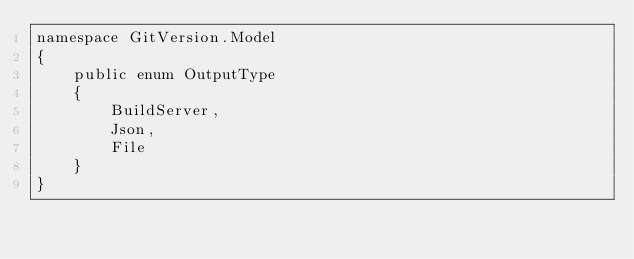Convert code to text. <code><loc_0><loc_0><loc_500><loc_500><_C#_>namespace GitVersion.Model
{
    public enum OutputType
    {
        BuildServer,
        Json,
        File
    }
}
</code> 